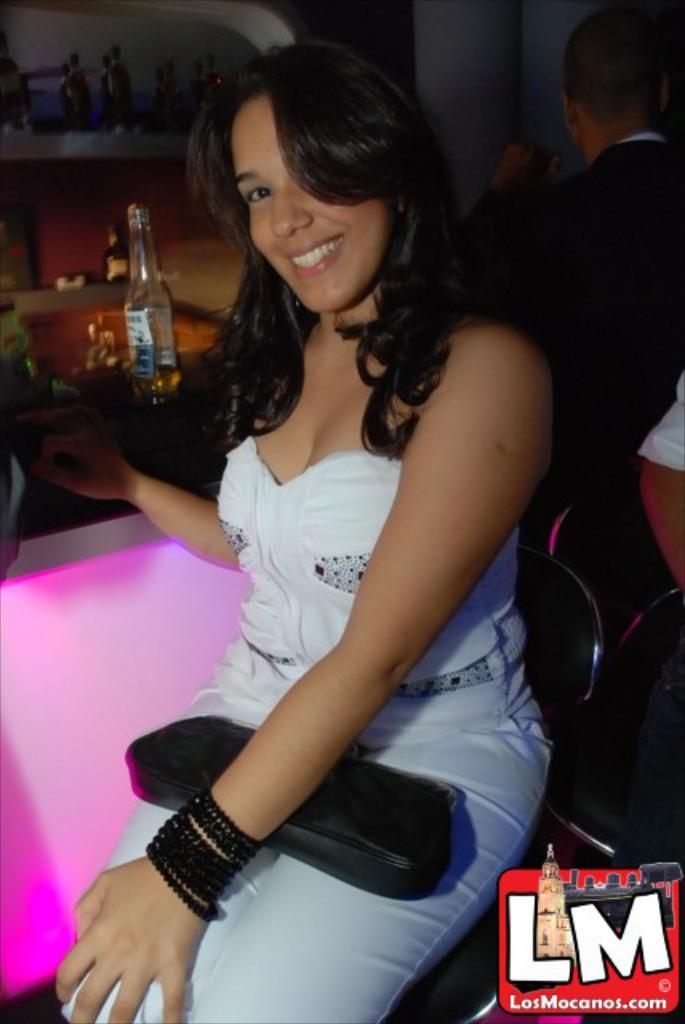Who is the main subject in the image? There is a woman in the image. What is the woman doing in the image? The woman is sitting on a chair and smiling. What can be seen behind the woman? There is a wine bottle behind the woman. Are there any other people in the image? Yes, there are people around the woman. What type of mark does the pig leave on the floor in the image? There is no pig present in the image, so it is not possible to determine what type of mark it might leave on the floor. 